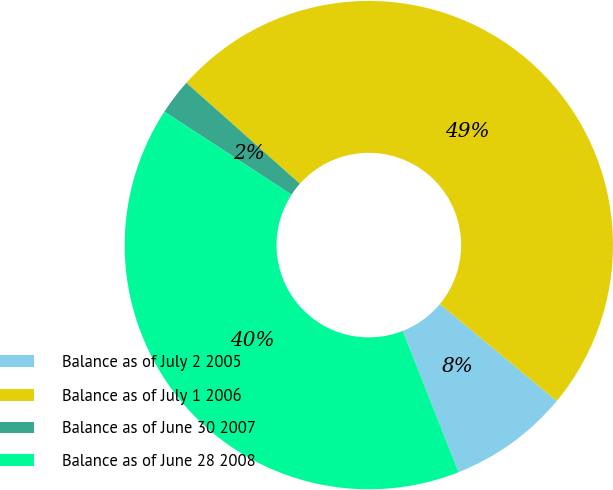Convert chart to OTSL. <chart><loc_0><loc_0><loc_500><loc_500><pie_chart><fcel>Balance as of July 2 2005<fcel>Balance as of July 1 2006<fcel>Balance as of June 30 2007<fcel>Balance as of June 28 2008<nl><fcel>7.99%<fcel>49.45%<fcel>2.37%<fcel>40.19%<nl></chart> 